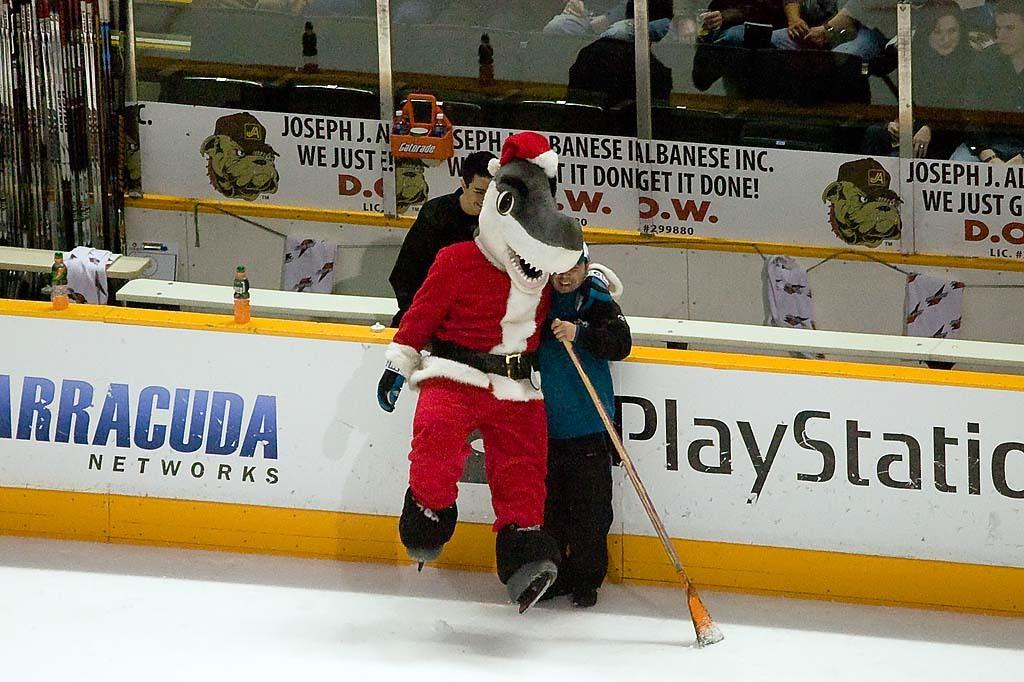<image>
Give a short and clear explanation of the subsequent image. a hockey rink with PlayStation on the boards 